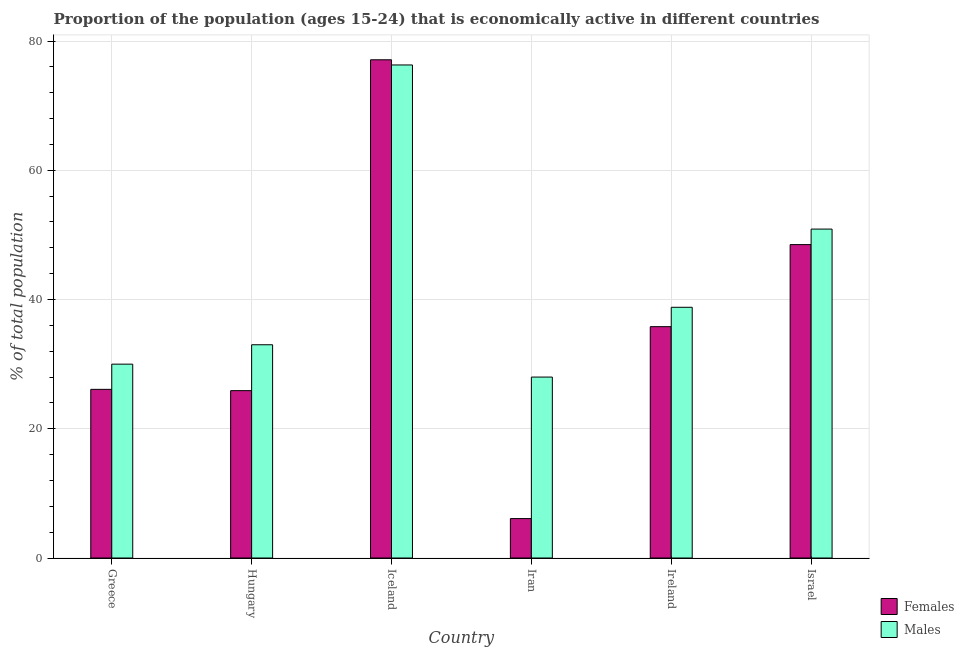Are the number of bars per tick equal to the number of legend labels?
Your answer should be compact. Yes. Are the number of bars on each tick of the X-axis equal?
Ensure brevity in your answer.  Yes. What is the label of the 3rd group of bars from the left?
Your response must be concise. Iceland. What is the percentage of economically active female population in Ireland?
Provide a short and direct response. 35.8. Across all countries, what is the maximum percentage of economically active male population?
Provide a succinct answer. 76.3. In which country was the percentage of economically active female population maximum?
Give a very brief answer. Iceland. In which country was the percentage of economically active female population minimum?
Provide a succinct answer. Iran. What is the total percentage of economically active female population in the graph?
Give a very brief answer. 219.5. What is the difference between the percentage of economically active female population in Iceland and that in Ireland?
Make the answer very short. 41.3. What is the difference between the percentage of economically active female population in Israel and the percentage of economically active male population in Hungary?
Your answer should be very brief. 15.5. What is the average percentage of economically active male population per country?
Give a very brief answer. 42.83. What is the difference between the percentage of economically active female population and percentage of economically active male population in Iran?
Give a very brief answer. -21.9. What is the ratio of the percentage of economically active female population in Greece to that in Iran?
Give a very brief answer. 4.28. Is the difference between the percentage of economically active female population in Greece and Hungary greater than the difference between the percentage of economically active male population in Greece and Hungary?
Your answer should be compact. Yes. What is the difference between the highest and the second highest percentage of economically active male population?
Provide a short and direct response. 25.4. What is the difference between the highest and the lowest percentage of economically active male population?
Offer a terse response. 48.3. Is the sum of the percentage of economically active female population in Iceland and Ireland greater than the maximum percentage of economically active male population across all countries?
Provide a succinct answer. Yes. What does the 2nd bar from the left in Israel represents?
Your answer should be compact. Males. What does the 1st bar from the right in Ireland represents?
Offer a terse response. Males. How many bars are there?
Provide a short and direct response. 12. Are all the bars in the graph horizontal?
Offer a very short reply. No. What is the difference between two consecutive major ticks on the Y-axis?
Provide a succinct answer. 20. Are the values on the major ticks of Y-axis written in scientific E-notation?
Offer a very short reply. No. Does the graph contain any zero values?
Your answer should be very brief. No. Does the graph contain grids?
Your answer should be very brief. Yes. Where does the legend appear in the graph?
Ensure brevity in your answer.  Bottom right. What is the title of the graph?
Give a very brief answer. Proportion of the population (ages 15-24) that is economically active in different countries. Does "Import" appear as one of the legend labels in the graph?
Your answer should be compact. No. What is the label or title of the Y-axis?
Give a very brief answer. % of total population. What is the % of total population of Females in Greece?
Provide a short and direct response. 26.1. What is the % of total population of Females in Hungary?
Your answer should be compact. 25.9. What is the % of total population of Females in Iceland?
Give a very brief answer. 77.1. What is the % of total population of Males in Iceland?
Offer a very short reply. 76.3. What is the % of total population in Females in Iran?
Your answer should be compact. 6.1. What is the % of total population of Males in Iran?
Provide a short and direct response. 28. What is the % of total population of Females in Ireland?
Offer a terse response. 35.8. What is the % of total population of Males in Ireland?
Provide a short and direct response. 38.8. What is the % of total population in Females in Israel?
Make the answer very short. 48.5. What is the % of total population of Males in Israel?
Ensure brevity in your answer.  50.9. Across all countries, what is the maximum % of total population in Females?
Ensure brevity in your answer.  77.1. Across all countries, what is the maximum % of total population of Males?
Offer a terse response. 76.3. Across all countries, what is the minimum % of total population in Females?
Ensure brevity in your answer.  6.1. What is the total % of total population in Females in the graph?
Ensure brevity in your answer.  219.5. What is the total % of total population of Males in the graph?
Give a very brief answer. 257. What is the difference between the % of total population in Females in Greece and that in Hungary?
Offer a very short reply. 0.2. What is the difference between the % of total population in Males in Greece and that in Hungary?
Your answer should be compact. -3. What is the difference between the % of total population in Females in Greece and that in Iceland?
Your answer should be very brief. -51. What is the difference between the % of total population of Males in Greece and that in Iceland?
Your response must be concise. -46.3. What is the difference between the % of total population of Females in Greece and that in Ireland?
Provide a short and direct response. -9.7. What is the difference between the % of total population in Males in Greece and that in Ireland?
Ensure brevity in your answer.  -8.8. What is the difference between the % of total population of Females in Greece and that in Israel?
Offer a terse response. -22.4. What is the difference between the % of total population of Males in Greece and that in Israel?
Provide a succinct answer. -20.9. What is the difference between the % of total population in Females in Hungary and that in Iceland?
Your answer should be very brief. -51.2. What is the difference between the % of total population in Males in Hungary and that in Iceland?
Make the answer very short. -43.3. What is the difference between the % of total population in Females in Hungary and that in Iran?
Make the answer very short. 19.8. What is the difference between the % of total population of Males in Hungary and that in Ireland?
Offer a terse response. -5.8. What is the difference between the % of total population of Females in Hungary and that in Israel?
Keep it short and to the point. -22.6. What is the difference between the % of total population in Males in Hungary and that in Israel?
Give a very brief answer. -17.9. What is the difference between the % of total population of Males in Iceland and that in Iran?
Provide a short and direct response. 48.3. What is the difference between the % of total population in Females in Iceland and that in Ireland?
Your response must be concise. 41.3. What is the difference between the % of total population in Males in Iceland and that in Ireland?
Make the answer very short. 37.5. What is the difference between the % of total population in Females in Iceland and that in Israel?
Your answer should be compact. 28.6. What is the difference between the % of total population of Males in Iceland and that in Israel?
Provide a succinct answer. 25.4. What is the difference between the % of total population of Females in Iran and that in Ireland?
Offer a very short reply. -29.7. What is the difference between the % of total population in Females in Iran and that in Israel?
Offer a very short reply. -42.4. What is the difference between the % of total population of Males in Iran and that in Israel?
Make the answer very short. -22.9. What is the difference between the % of total population in Females in Greece and the % of total population in Males in Hungary?
Provide a short and direct response. -6.9. What is the difference between the % of total population of Females in Greece and the % of total population of Males in Iceland?
Offer a terse response. -50.2. What is the difference between the % of total population of Females in Greece and the % of total population of Males in Iran?
Offer a terse response. -1.9. What is the difference between the % of total population in Females in Greece and the % of total population in Males in Ireland?
Give a very brief answer. -12.7. What is the difference between the % of total population of Females in Greece and the % of total population of Males in Israel?
Provide a short and direct response. -24.8. What is the difference between the % of total population of Females in Hungary and the % of total population of Males in Iceland?
Keep it short and to the point. -50.4. What is the difference between the % of total population in Females in Hungary and the % of total population in Males in Iran?
Keep it short and to the point. -2.1. What is the difference between the % of total population of Females in Iceland and the % of total population of Males in Iran?
Ensure brevity in your answer.  49.1. What is the difference between the % of total population in Females in Iceland and the % of total population in Males in Ireland?
Provide a short and direct response. 38.3. What is the difference between the % of total population of Females in Iceland and the % of total population of Males in Israel?
Provide a succinct answer. 26.2. What is the difference between the % of total population of Females in Iran and the % of total population of Males in Ireland?
Ensure brevity in your answer.  -32.7. What is the difference between the % of total population in Females in Iran and the % of total population in Males in Israel?
Offer a terse response. -44.8. What is the difference between the % of total population in Females in Ireland and the % of total population in Males in Israel?
Provide a short and direct response. -15.1. What is the average % of total population in Females per country?
Your response must be concise. 36.58. What is the average % of total population of Males per country?
Your answer should be compact. 42.83. What is the difference between the % of total population of Females and % of total population of Males in Greece?
Offer a very short reply. -3.9. What is the difference between the % of total population of Females and % of total population of Males in Iran?
Give a very brief answer. -21.9. What is the ratio of the % of total population in Females in Greece to that in Hungary?
Provide a succinct answer. 1.01. What is the ratio of the % of total population of Females in Greece to that in Iceland?
Your response must be concise. 0.34. What is the ratio of the % of total population in Males in Greece to that in Iceland?
Offer a very short reply. 0.39. What is the ratio of the % of total population of Females in Greece to that in Iran?
Provide a short and direct response. 4.28. What is the ratio of the % of total population of Males in Greece to that in Iran?
Make the answer very short. 1.07. What is the ratio of the % of total population in Females in Greece to that in Ireland?
Provide a succinct answer. 0.73. What is the ratio of the % of total population in Males in Greece to that in Ireland?
Offer a terse response. 0.77. What is the ratio of the % of total population in Females in Greece to that in Israel?
Your answer should be very brief. 0.54. What is the ratio of the % of total population in Males in Greece to that in Israel?
Your answer should be compact. 0.59. What is the ratio of the % of total population of Females in Hungary to that in Iceland?
Give a very brief answer. 0.34. What is the ratio of the % of total population in Males in Hungary to that in Iceland?
Offer a terse response. 0.43. What is the ratio of the % of total population of Females in Hungary to that in Iran?
Offer a very short reply. 4.25. What is the ratio of the % of total population of Males in Hungary to that in Iran?
Your answer should be very brief. 1.18. What is the ratio of the % of total population of Females in Hungary to that in Ireland?
Provide a short and direct response. 0.72. What is the ratio of the % of total population in Males in Hungary to that in Ireland?
Provide a succinct answer. 0.85. What is the ratio of the % of total population in Females in Hungary to that in Israel?
Your answer should be compact. 0.53. What is the ratio of the % of total population in Males in Hungary to that in Israel?
Your response must be concise. 0.65. What is the ratio of the % of total population of Females in Iceland to that in Iran?
Give a very brief answer. 12.64. What is the ratio of the % of total population in Males in Iceland to that in Iran?
Keep it short and to the point. 2.73. What is the ratio of the % of total population of Females in Iceland to that in Ireland?
Keep it short and to the point. 2.15. What is the ratio of the % of total population of Males in Iceland to that in Ireland?
Offer a very short reply. 1.97. What is the ratio of the % of total population in Females in Iceland to that in Israel?
Provide a short and direct response. 1.59. What is the ratio of the % of total population of Males in Iceland to that in Israel?
Make the answer very short. 1.5. What is the ratio of the % of total population in Females in Iran to that in Ireland?
Your answer should be very brief. 0.17. What is the ratio of the % of total population in Males in Iran to that in Ireland?
Keep it short and to the point. 0.72. What is the ratio of the % of total population of Females in Iran to that in Israel?
Provide a succinct answer. 0.13. What is the ratio of the % of total population of Males in Iran to that in Israel?
Provide a short and direct response. 0.55. What is the ratio of the % of total population of Females in Ireland to that in Israel?
Make the answer very short. 0.74. What is the ratio of the % of total population in Males in Ireland to that in Israel?
Provide a short and direct response. 0.76. What is the difference between the highest and the second highest % of total population in Females?
Your response must be concise. 28.6. What is the difference between the highest and the second highest % of total population of Males?
Keep it short and to the point. 25.4. What is the difference between the highest and the lowest % of total population in Females?
Provide a short and direct response. 71. What is the difference between the highest and the lowest % of total population of Males?
Ensure brevity in your answer.  48.3. 